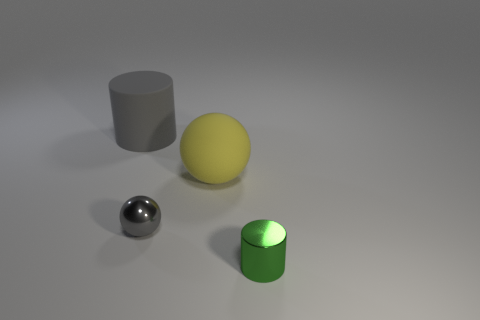Add 2 tiny metallic things. How many objects exist? 6 Subtract 1 spheres. How many spheres are left? 1 Add 3 cyan cubes. How many cyan cubes exist? 3 Subtract 0 yellow blocks. How many objects are left? 4 Subtract all gray cylinders. Subtract all brown cubes. How many cylinders are left? 1 Subtract all gray cubes. How many brown spheres are left? 0 Subtract all cyan matte spheres. Subtract all large spheres. How many objects are left? 3 Add 3 large gray rubber objects. How many large gray rubber objects are left? 4 